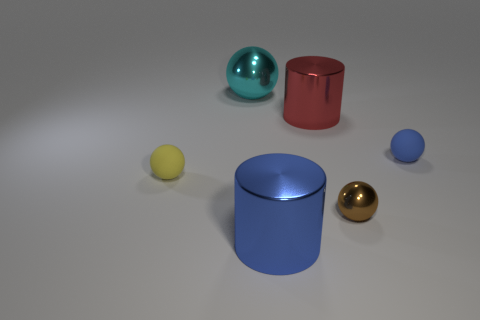There is a red thing; how many large blue cylinders are on the left side of it?
Your answer should be very brief. 1. Are there any big yellow cylinders?
Your response must be concise. No. There is a rubber object behind the small matte ball to the left of the small blue matte sphere that is on the right side of the big cyan metallic object; what is its color?
Make the answer very short. Blue. Are there any tiny brown metal objects on the left side of the cylinder behind the small blue rubber thing?
Offer a very short reply. No. Does the rubber ball to the right of the large cyan shiny thing have the same color as the ball that is in front of the small yellow thing?
Provide a short and direct response. No. What number of cyan spheres are the same size as the blue cylinder?
Provide a succinct answer. 1. Is the size of the metal sphere that is in front of the blue matte ball the same as the big cyan metallic sphere?
Your answer should be very brief. No. The red thing is what shape?
Offer a terse response. Cylinder. Is the small ball behind the yellow object made of the same material as the big cyan ball?
Offer a terse response. No. Is there another metallic ball that has the same color as the small metal ball?
Keep it short and to the point. No. 